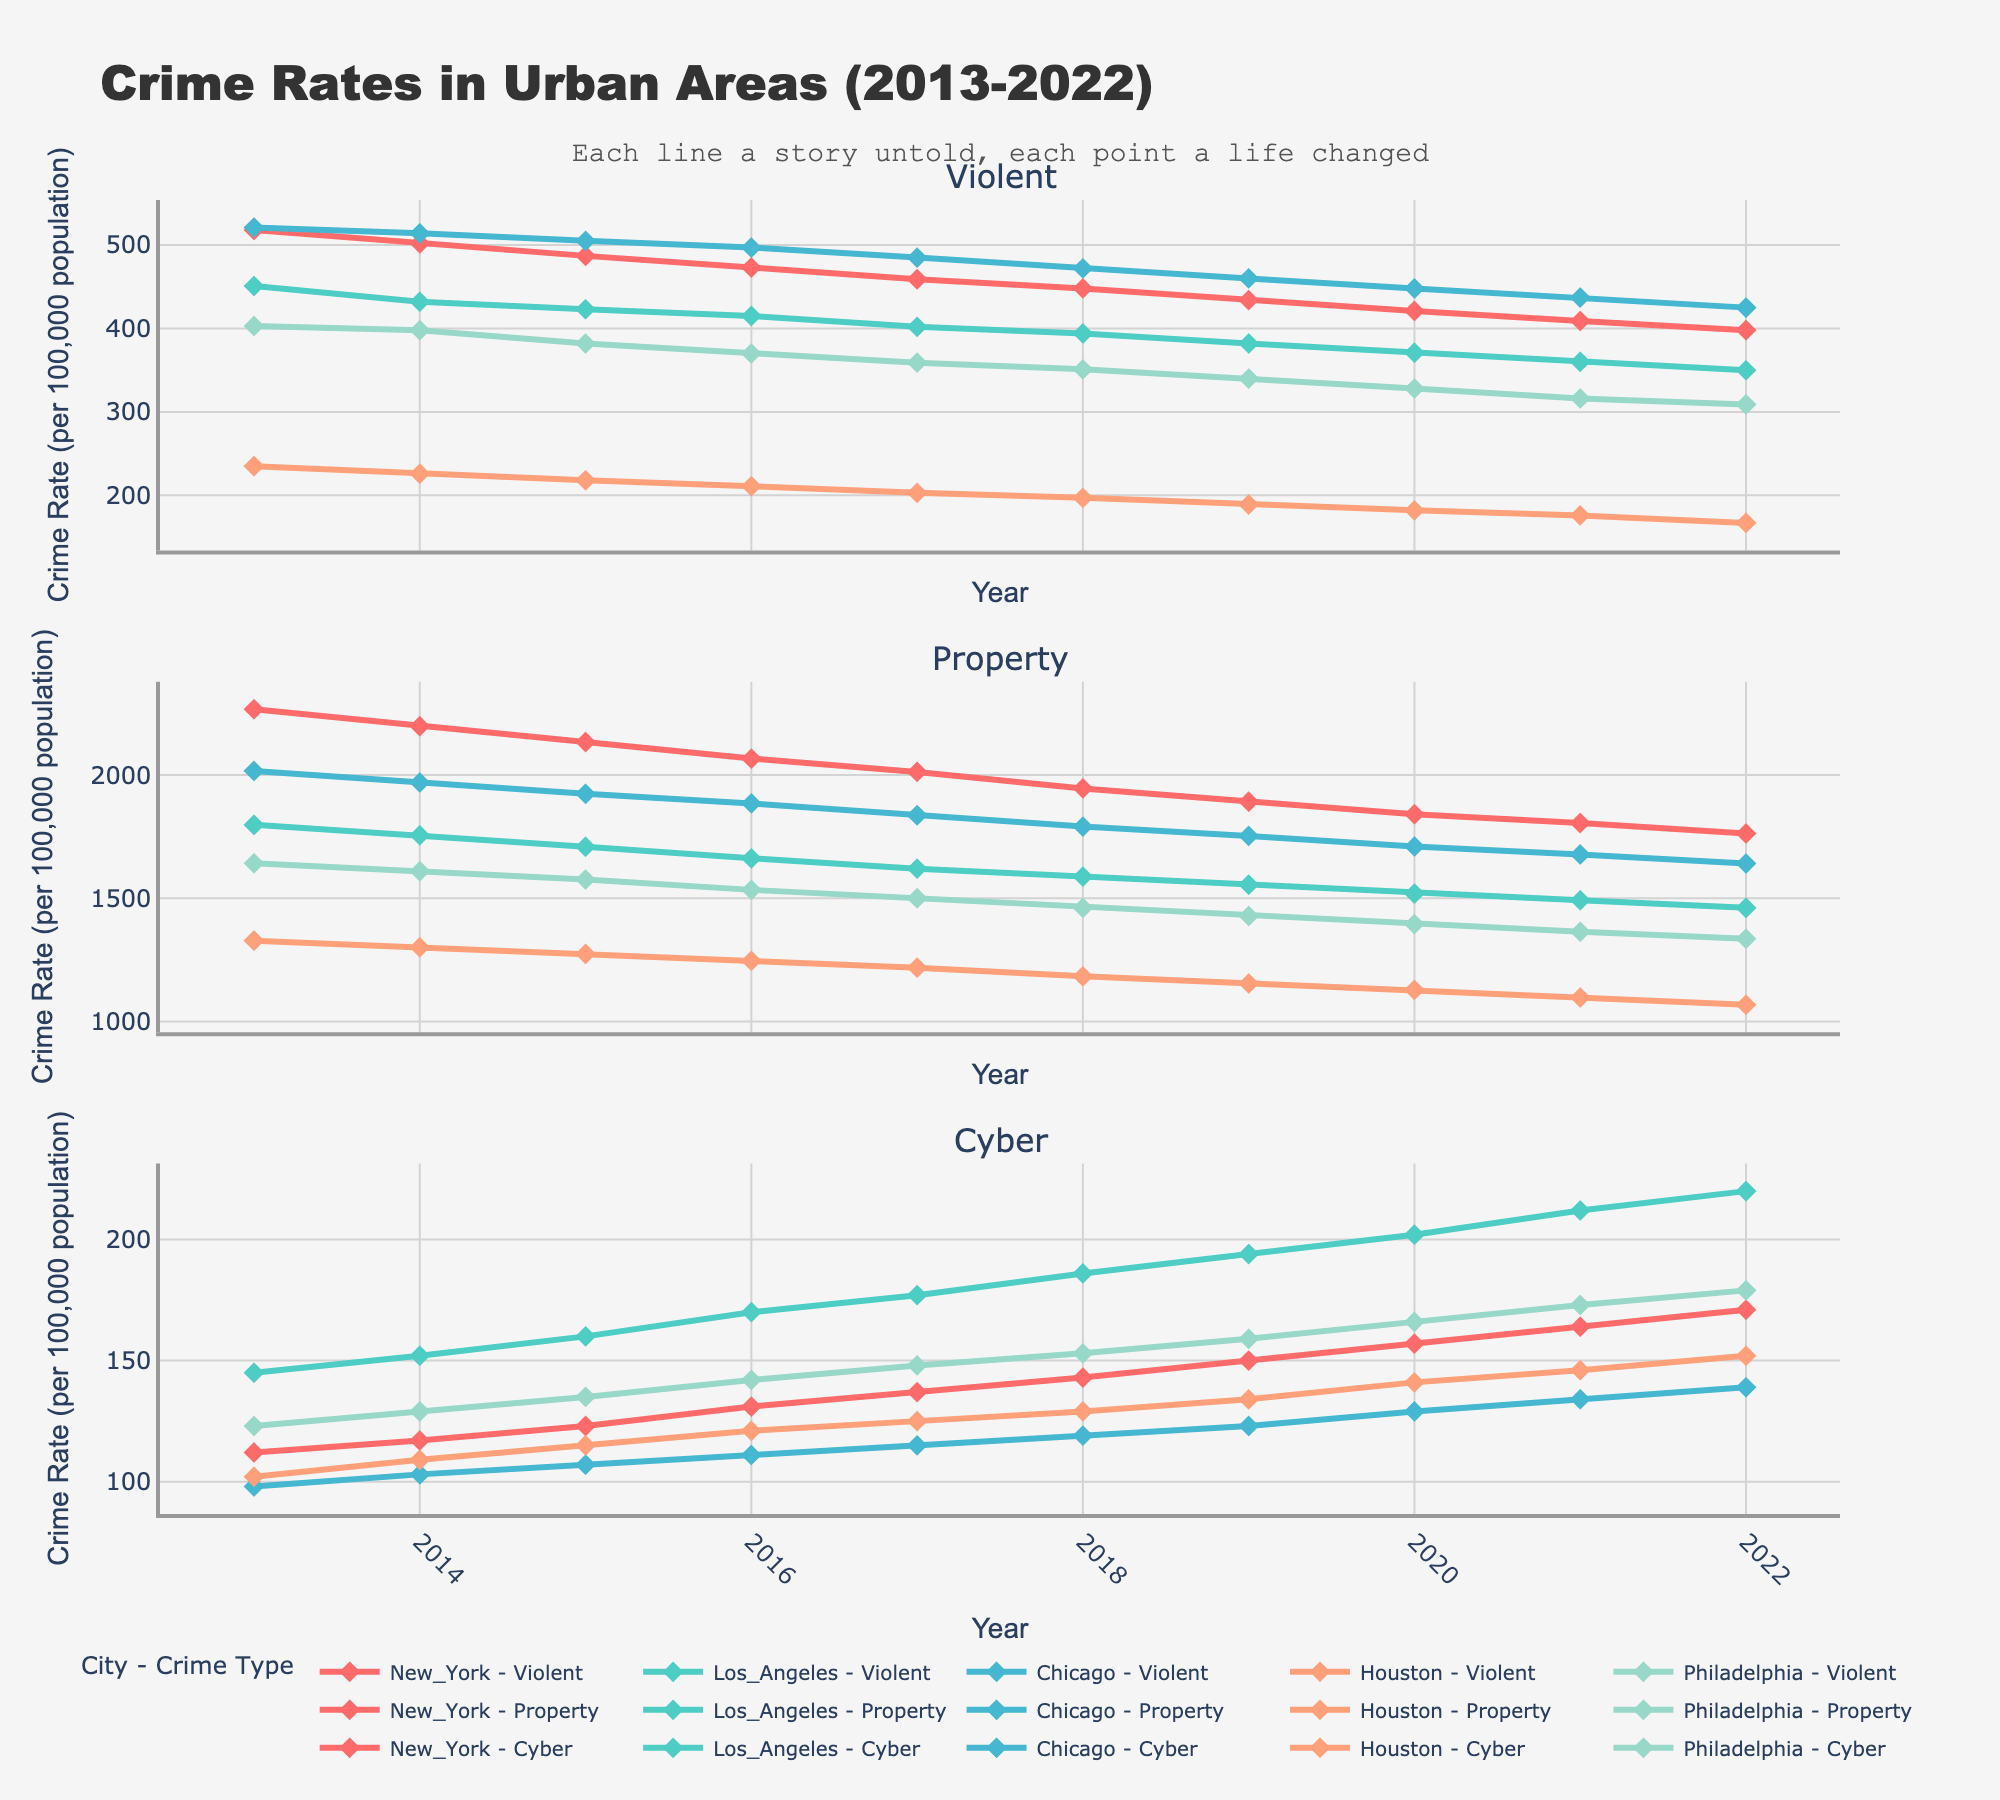What is the title of the figure? The title is usually prominently displayed at the top of the figure. It is "Crime Rates in Urban Areas (2013-2022)" as stated in the code.
Answer: Crime Rates in Urban Areas (2013-2022) How many types of crimes are tracked in the figure? The figure has three subplots, each representing a different type of crime. They are "Violent", "Property", and "Cyber".
Answer: 3 Which city shows the highest violent crime rate in 2022? To determine this, look at the data points on the subplot for Violent crime in 2022. Compare the values for all cities. The highest value will indicate the city with the highest violent crime rate. New York has the highest value of 398.
Answer: New York What was the trend in property crime rates in Chicago from 2013 to 2022? Locate the subplot for Property crime and follow the line corresponding to Chicago (might be distinguished by color and legend). Observe how the rate changes over time from 2013 to 2022. There is a general downward trend.
Answer: Downward trend What year saw the highest rate of cybercrime in total among all cities? Compare the heights of the data points across all cities for each year in the Cyber crime subplot. Look for the year with the highest accumulated value. 2022 shows the highest rates overall.
Answer: 2022 How did the violent crime rates in Philadelphia change between 2013 and 2022? In the Violent crime subplot, follow the line for Philadelphia from 2013 to 2022. Observe if the values are increasing, decreasing, or fluctuating. The overall trend is decreasing from 403 to 309.
Answer: Decreasing Which city had the lowest cybercrime rate in 2020, and what was the rate? Check the Cyber crime subplot for the year 2020 and compare the values for all cities. Houston has the lowest rate with a value of 141.
Answer: Houston, 141 Is there a consistent pattern in the property crime rate for Los Angeles throughout the years? In the Property crime subplot, follow the line for Los Angeles from 2013 to 2022. Check if the pattern shows a consistent increase, decrease, or alternation. The pattern shows a consistent decrease.
Answer: Consistent decrease Compare the trend in cybercrime rates between New York and Los Angeles from 2013 to 2022. Look at the Cyber crime subplot and compare the lines for New York and Los Angeles. Analyze if the trends follow similar trajectories, diverge, or intersect. Both cities show an increasing trend, but Los Angeles has a sharper increase.
Answer: Both increasing, Los Angeles sharper increase 